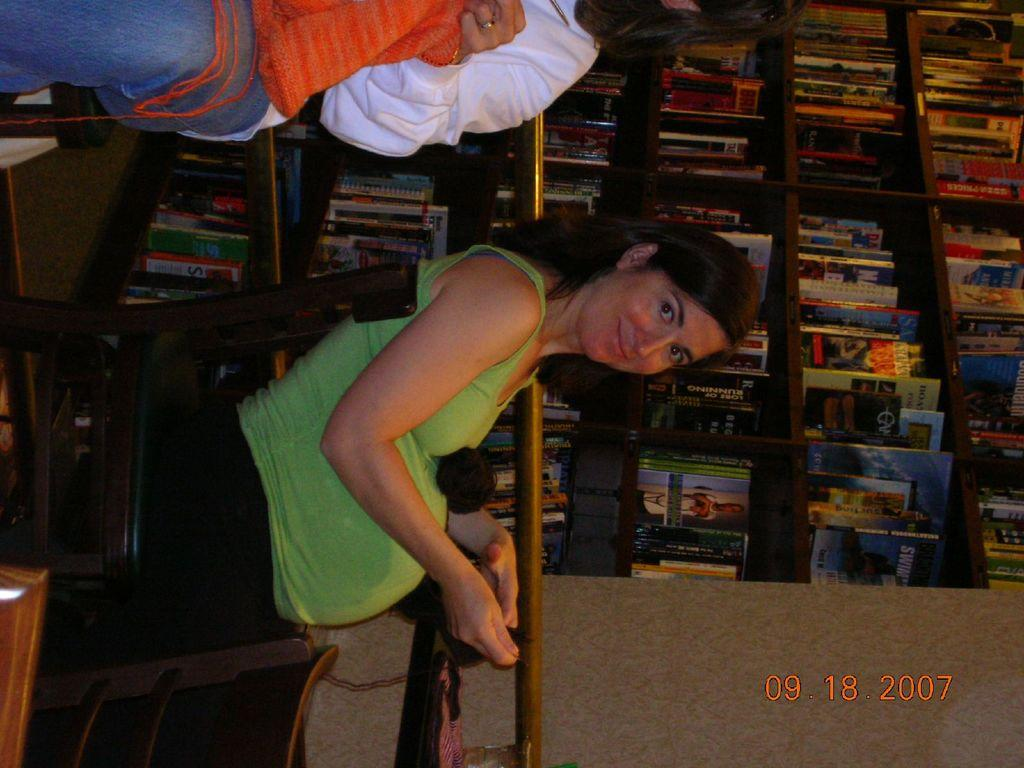Who is the main subject in the image? There is a woman in the image. What is the woman doing in the image? The woman is sitting in a chair. What is the woman wearing in the image? The woman is wearing a green dress. What is the woman's facial expression in the image? The woman is smiling. What can be seen in the background of the image? There is a bookshelf in the background of the image. What type of van does the governor use to travel in the image? There is no van or governor present in the image; it features a woman sitting in a chair. Is the woman wearing a scarf in the image? No, the woman is wearing a green dress, not a scarf. 